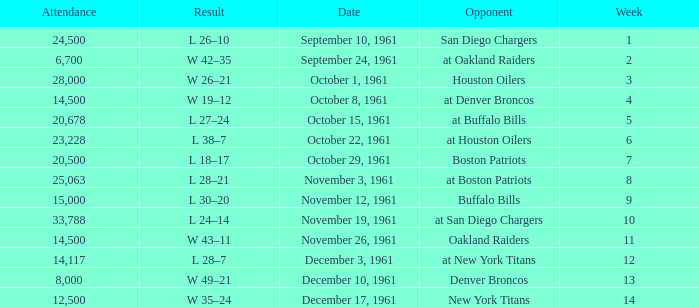What is the low week from october 15, 1961? 5.0. 